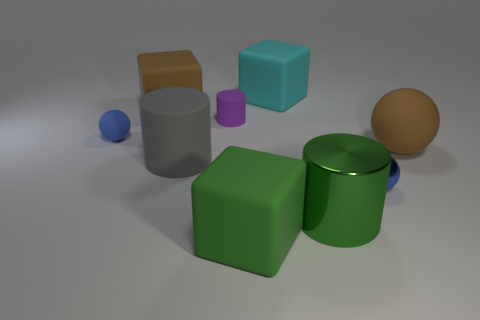How many big things are either metal balls or brown metallic balls?
Ensure brevity in your answer.  0. Are there more big rubber balls than big brown objects?
Provide a succinct answer. No. Does the big gray cylinder have the same material as the small cylinder?
Offer a terse response. Yes. Is there anything else that has the same material as the big brown ball?
Offer a very short reply. Yes. Are there more brown things right of the large brown rubber ball than tiny blue things?
Give a very brief answer. No. Is the color of the big shiny thing the same as the big matte cylinder?
Your answer should be very brief. No. What number of big gray matte objects have the same shape as the tiny blue matte thing?
Offer a terse response. 0. There is a purple cylinder that is made of the same material as the large brown sphere; what is its size?
Offer a terse response. Small. There is a large object that is on the right side of the large green matte thing and in front of the small shiny ball; what is its color?
Your answer should be compact. Green. How many spheres have the same size as the green metal cylinder?
Keep it short and to the point. 1. 